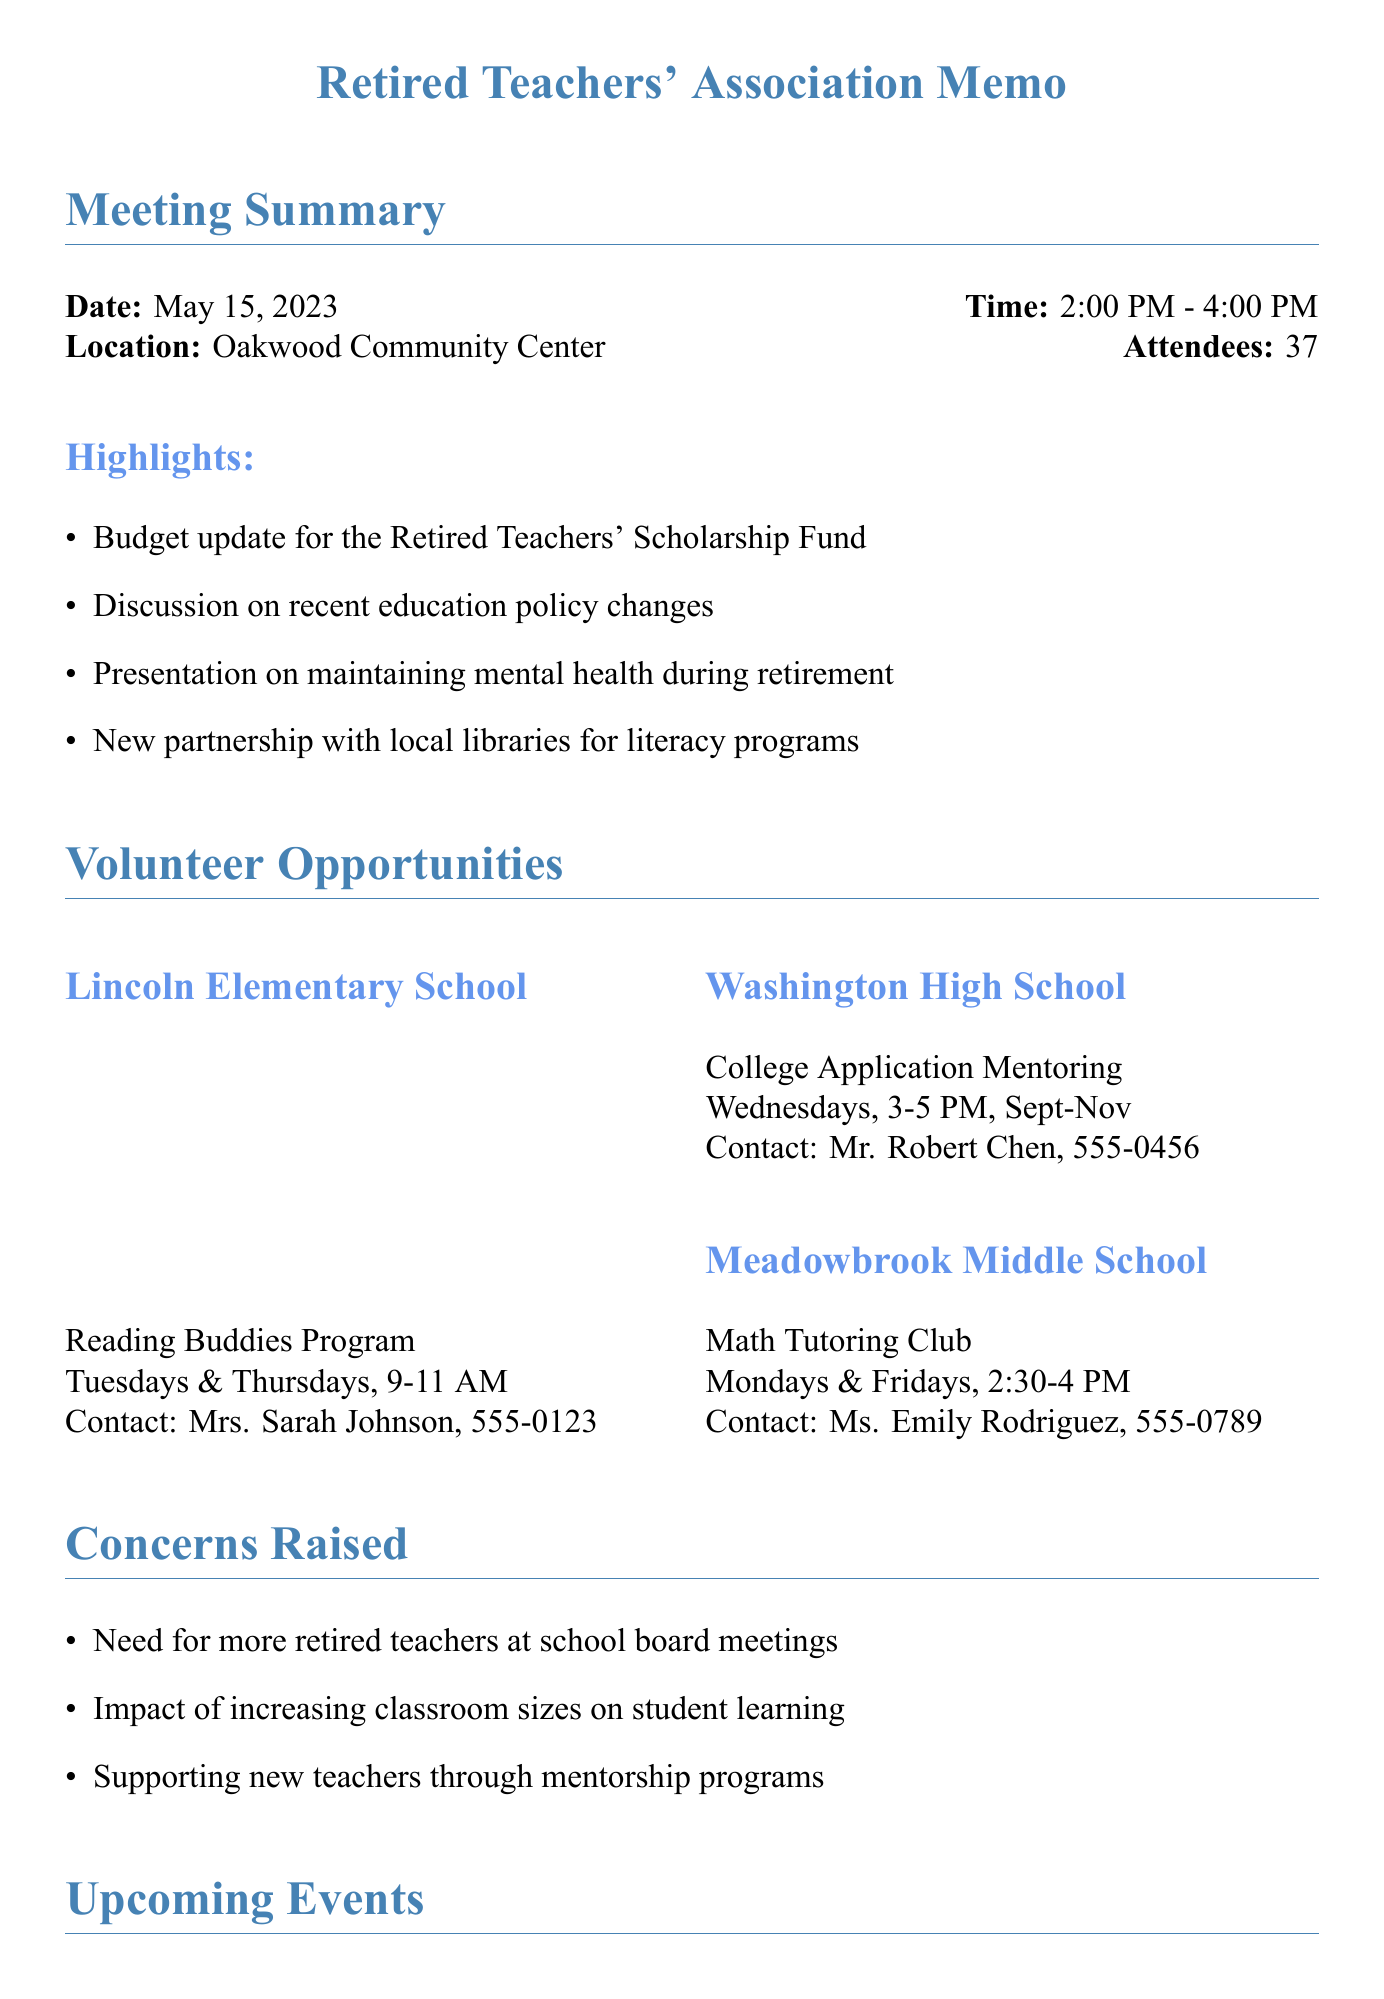What date was the meeting held? The date of the meeting is explicitly mentioned in the document as May 15, 2023.
Answer: May 15, 2023 Who is the contact person for the Reading Buddies Program? The document states that Mrs. Sarah Johnson is the contact person for the Reading Buddies Program at Lincoln Elementary School.
Answer: Mrs. Sarah Johnson What is the activity scheduled at Washington High School? The document lists the College Application Mentoring as the activity at Washington High School.
Answer: College Application Mentoring Which school offers a Math Tutoring Club? The document specifies that Meadowbrook Middle School offers a Math Tutoring Club.
Answer: Meadowbrook Middle School When is the Annual Retired Teachers' Picnic? The document clearly states that the picnic is scheduled for July 8, 2023.
Answer: July 8, 2023 What are the meeting attendees' concerns about classroom sizes? One of the concerns raised in the meeting is about the impact of increasing classroom sizes on student learning.
Answer: Increasing classroom sizes How often do the Reading Buddies meet? The document mentions that the Reading Buddies Program meets every Tuesday and Thursday.
Answer: Every Tuesday and Thursday What is the purpose of the Education Policy Workshop? The workshop aims to provide insight into education policy, with a speaker listed as an expert in the document.
Answer: Education policy insights What action item involves teachers? The action item mentions "seek input from current teachers on support needs" as a specific action.
Answer: Seek input from current teachers 